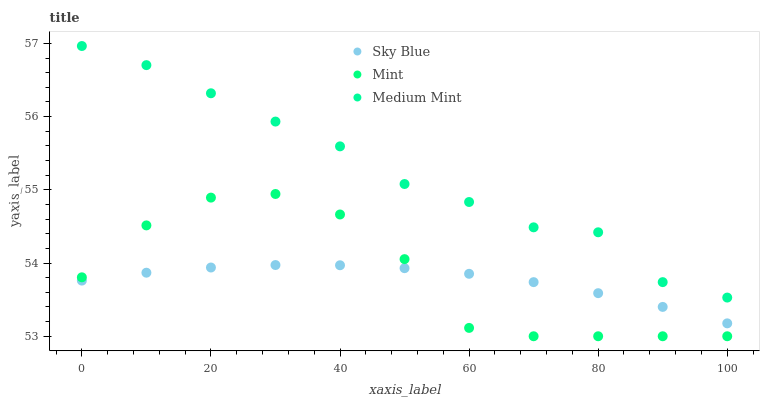Does Sky Blue have the minimum area under the curve?
Answer yes or no. Yes. Does Medium Mint have the maximum area under the curve?
Answer yes or no. Yes. Does Mint have the minimum area under the curve?
Answer yes or no. No. Does Mint have the maximum area under the curve?
Answer yes or no. No. Is Sky Blue the smoothest?
Answer yes or no. Yes. Is Mint the roughest?
Answer yes or no. Yes. Is Mint the smoothest?
Answer yes or no. No. Is Sky Blue the roughest?
Answer yes or no. No. Does Mint have the lowest value?
Answer yes or no. Yes. Does Sky Blue have the lowest value?
Answer yes or no. No. Does Medium Mint have the highest value?
Answer yes or no. Yes. Does Mint have the highest value?
Answer yes or no. No. Is Sky Blue less than Medium Mint?
Answer yes or no. Yes. Is Medium Mint greater than Sky Blue?
Answer yes or no. Yes. Does Mint intersect Sky Blue?
Answer yes or no. Yes. Is Mint less than Sky Blue?
Answer yes or no. No. Is Mint greater than Sky Blue?
Answer yes or no. No. Does Sky Blue intersect Medium Mint?
Answer yes or no. No. 